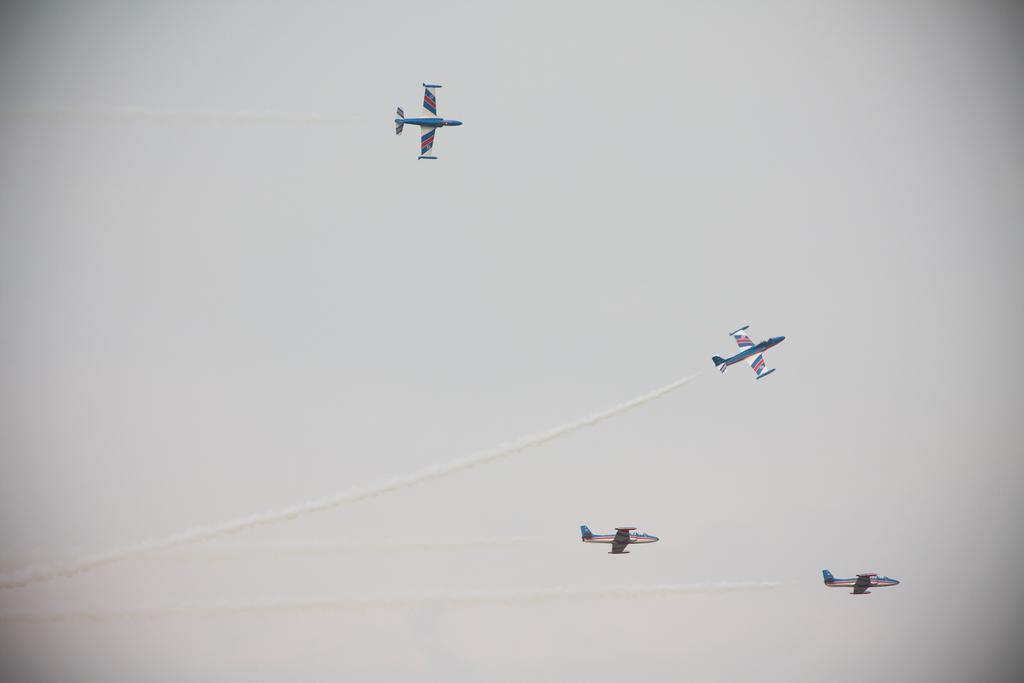Could you give a brief overview of what you see in this image? In this image there are four airplanes flying in the sky. There are contrails in the sky. In the background there is the sky. 